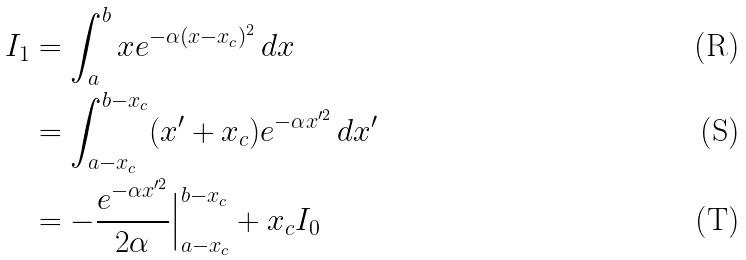Convert formula to latex. <formula><loc_0><loc_0><loc_500><loc_500>I _ { 1 } & = \int _ { a } ^ { b } x e ^ { - \alpha ( x - x _ { c } ) ^ { 2 } } \, d x \\ & = \int _ { a - x _ { c } } ^ { b - x _ { c } } ( x ^ { \prime } + x _ { c } ) e ^ { - \alpha x ^ { \prime 2 } } \, d x ^ { \prime } \\ & = - \frac { e ^ { - \alpha x ^ { \prime 2 } } } { 2 \alpha } \Big | _ { a - x _ { c } } ^ { b - x _ { c } } + x _ { c } I _ { 0 }</formula> 